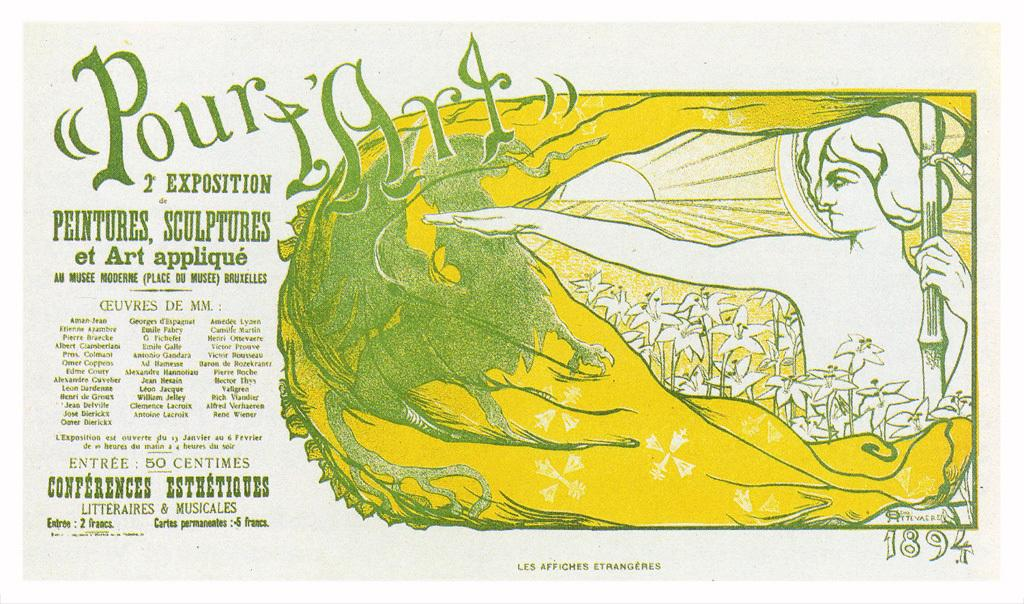<image>
Relay a brief, clear account of the picture shown. A french poster with a lady and a green dragon entitled Pour l'Art 